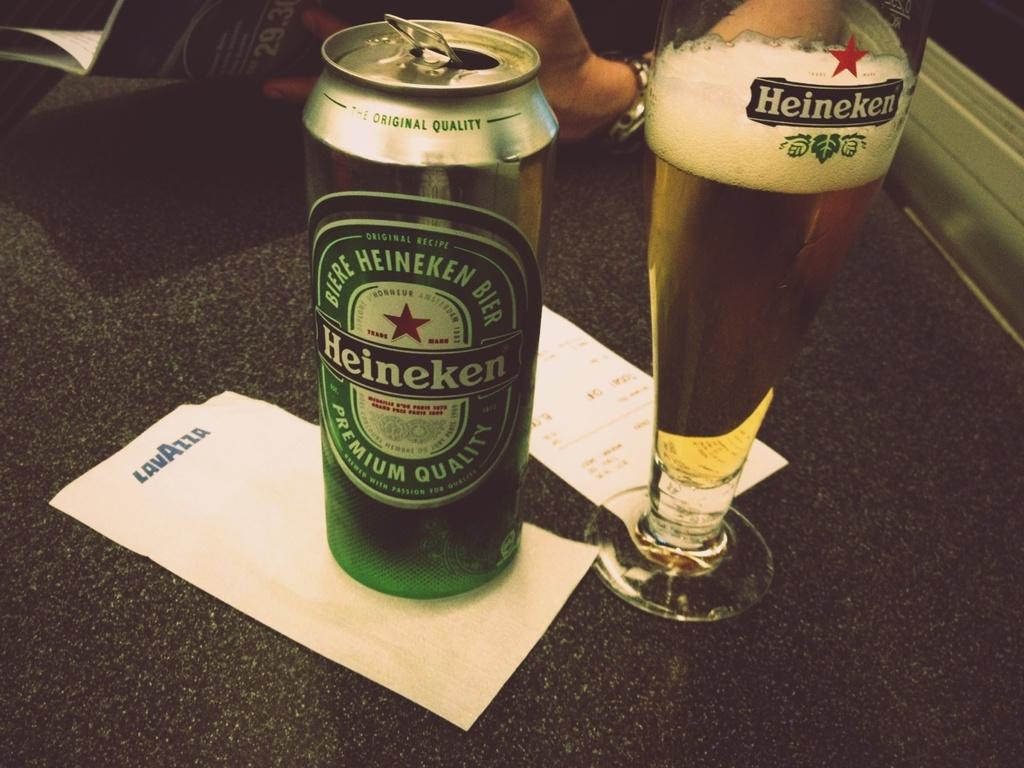Provide a one-sentence caption for the provided image. A tall can of Heinekan next to a fresh pour in a Heinekan glass. 